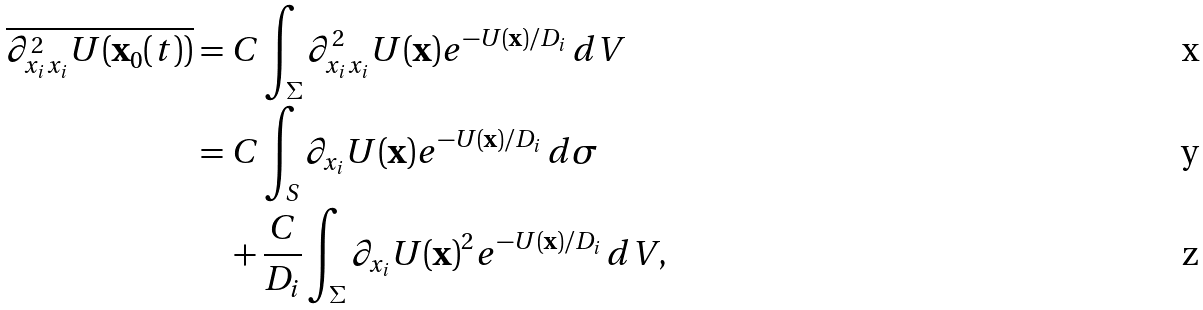<formula> <loc_0><loc_0><loc_500><loc_500>\overline { \partial ^ { 2 } _ { x _ { i } x _ { i } } U ( \mathbf x _ { 0 } ( t ) ) } & = C \int _ { \Sigma } \partial ^ { 2 } _ { x _ { i } x _ { i } } U ( \mathbf x ) e ^ { - U ( \mathbf x ) / D _ { i } } \, d V \\ & = C \int _ { S } \partial _ { x _ { i } } U ( \mathbf x ) e ^ { - U ( \mathbf x ) / D _ { i } } \, d \sigma \\ & \quad + \frac { C } { D _ { i } } \int _ { \Sigma } \partial _ { x _ { i } } U ( \mathbf x ) ^ { 2 } e ^ { - U ( \mathbf x ) / D _ { i } } \, d V ,</formula> 